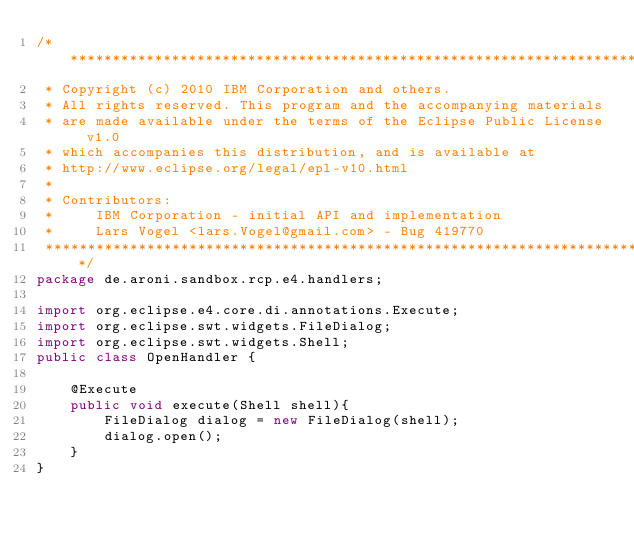Convert code to text. <code><loc_0><loc_0><loc_500><loc_500><_Java_>/*******************************************************************************
 * Copyright (c) 2010 IBM Corporation and others.
 * All rights reserved. This program and the accompanying materials
 * are made available under the terms of the Eclipse Public License v1.0
 * which accompanies this distribution, and is available at
 * http://www.eclipse.org/legal/epl-v10.html
 *
 * Contributors:
 *     IBM Corporation - initial API and implementation
 *     Lars Vogel <lars.Vogel@gmail.com> - Bug 419770
 *******************************************************************************/
package de.aroni.sandbox.rcp.e4.handlers;

import org.eclipse.e4.core.di.annotations.Execute;
import org.eclipse.swt.widgets.FileDialog;
import org.eclipse.swt.widgets.Shell;
public class OpenHandler {

	@Execute
	public void execute(Shell shell){
		FileDialog dialog = new FileDialog(shell);
		dialog.open();
	}
}
</code> 